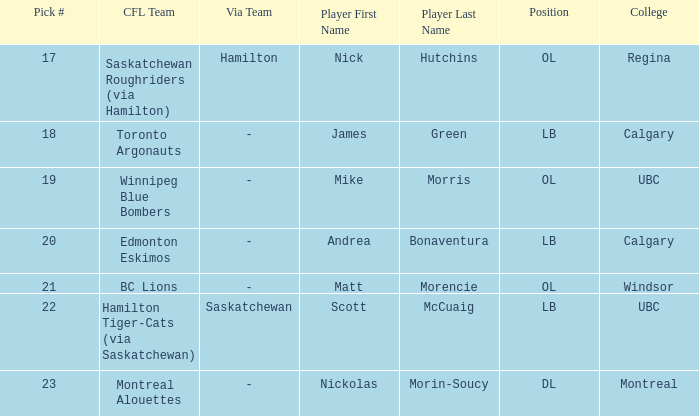Can you parse all the data within this table? {'header': ['Pick #', 'CFL Team', 'Via Team', 'Player First Name', 'Player Last Name', 'Position', 'College'], 'rows': [['17', 'Saskatchewan Roughriders (via Hamilton)', 'Hamilton', 'Nick', 'Hutchins', 'OL', 'Regina'], ['18', 'Toronto Argonauts', '-', 'James', 'Green', 'LB', 'Calgary'], ['19', 'Winnipeg Blue Bombers', '-', 'Mike', 'Morris', 'OL', 'UBC'], ['20', 'Edmonton Eskimos', '-', 'Andrea', 'Bonaventura', 'LB', 'Calgary'], ['21', 'BC Lions', '-', 'Matt', 'Morencie', 'OL', 'Windsor'], ['22', 'Hamilton Tiger-Cats (via Saskatchewan)', 'Saskatchewan', 'Scott', 'McCuaig', 'LB', 'UBC'], ['23', 'Montreal Alouettes', '-', 'Nickolas', 'Morin-Soucy', 'DL', 'Montreal']]} What number picks were the players who went to Calgary?  18, 20. 